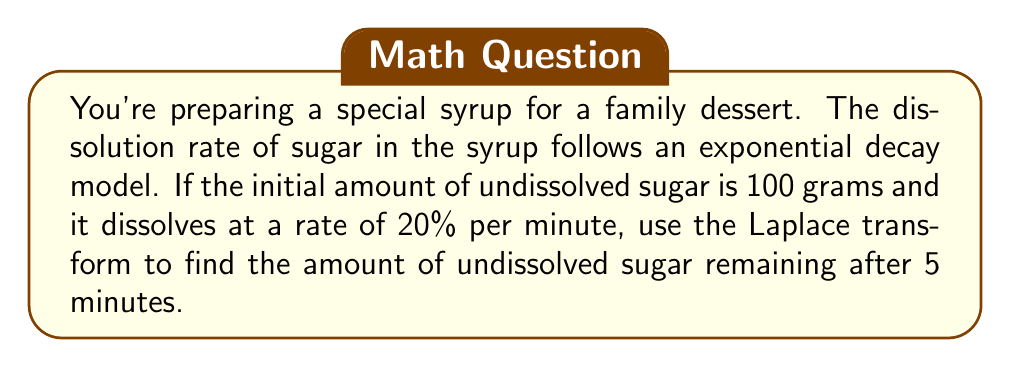Can you answer this question? Let's approach this step-by-step using Laplace transform techniques:

1) Let $S(t)$ be the amount of undissolved sugar at time $t$ (in minutes).

2) Given information:
   - Initial amount: $S(0) = 100$ grams
   - Decay rate: 20% per minute, or 0.2 per minute

3) The differential equation modeling this situation is:

   $$\frac{dS}{dt} = -0.2S$$

   with initial condition $S(0) = 100$

4) Taking the Laplace transform of both sides:

   $$\mathcal{L}\{\frac{dS}{dt}\} = \mathcal{L}\{-0.2S\}$$

5) Using the property of Laplace transform for derivatives:

   $$s\mathcal{L}\{S\} - S(0) = -0.2\mathcal{L}\{S\}$$

6) Let $\mathcal{L}\{S\} = \bar{S}(s)$. Substituting and rearranging:

   $$s\bar{S}(s) - 100 = -0.2\bar{S}(s)$$
   $$(s + 0.2)\bar{S}(s) = 100$$
   $$\bar{S}(s) = \frac{100}{s + 0.2}$$

7) This is the Laplace transform of $100e^{-0.2t}$. Therefore, the solution in the time domain is:

   $$S(t) = 100e^{-0.2t}$$

8) To find the amount of undissolved sugar after 5 minutes, evaluate $S(5)$:

   $$S(5) = 100e^{-0.2(5)} = 100e^{-1} \approx 36.79$$
Answer: The amount of undissolved sugar remaining after 5 minutes is approximately 36.79 grams. 